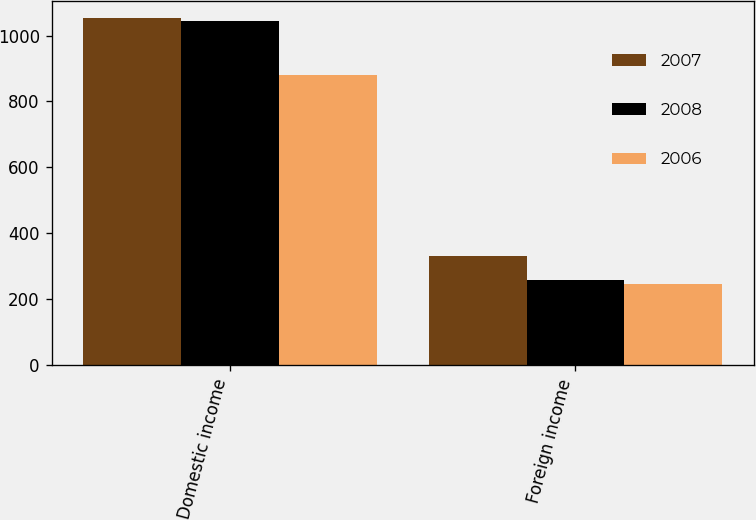Convert chart. <chart><loc_0><loc_0><loc_500><loc_500><stacked_bar_chart><ecel><fcel>Domestic income<fcel>Foreign income<nl><fcel>2007<fcel>1052<fcel>330<nl><fcel>2008<fcel>1044<fcel>260<nl><fcel>2006<fcel>879<fcel>245<nl></chart> 